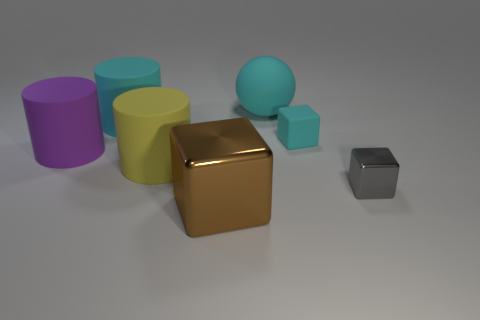There is a matte cylinder that is behind the rubber block; is its color the same as the tiny block in front of the small matte thing?
Provide a short and direct response. No. What is the size of the matte cylinder that is the same color as the tiny rubber object?
Your answer should be compact. Large. What number of other objects are the same size as the gray block?
Your response must be concise. 1. There is a tiny block that is in front of the yellow matte thing; what is its color?
Your answer should be compact. Gray. Is the block on the right side of the tiny cyan matte thing made of the same material as the yellow thing?
Your answer should be compact. No. How many big rubber objects are left of the cyan rubber cylinder and behind the cyan rubber cylinder?
Your answer should be compact. 0. There is a metallic thing that is left of the cyan matte object behind the cylinder that is behind the cyan cube; what color is it?
Make the answer very short. Brown. What number of other objects are the same shape as the large yellow rubber thing?
Provide a succinct answer. 2. There is a big cyan object on the right side of the large yellow matte thing; is there a big yellow matte thing right of it?
Ensure brevity in your answer.  No. What number of matte things are cylinders or big things?
Offer a terse response. 4. 